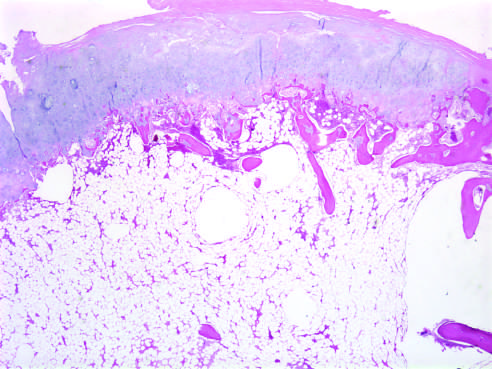what does the cartilage cap have?
Answer the question using a single word or phrase. The histologic appearance of disorganized growth plate-like cartilage 